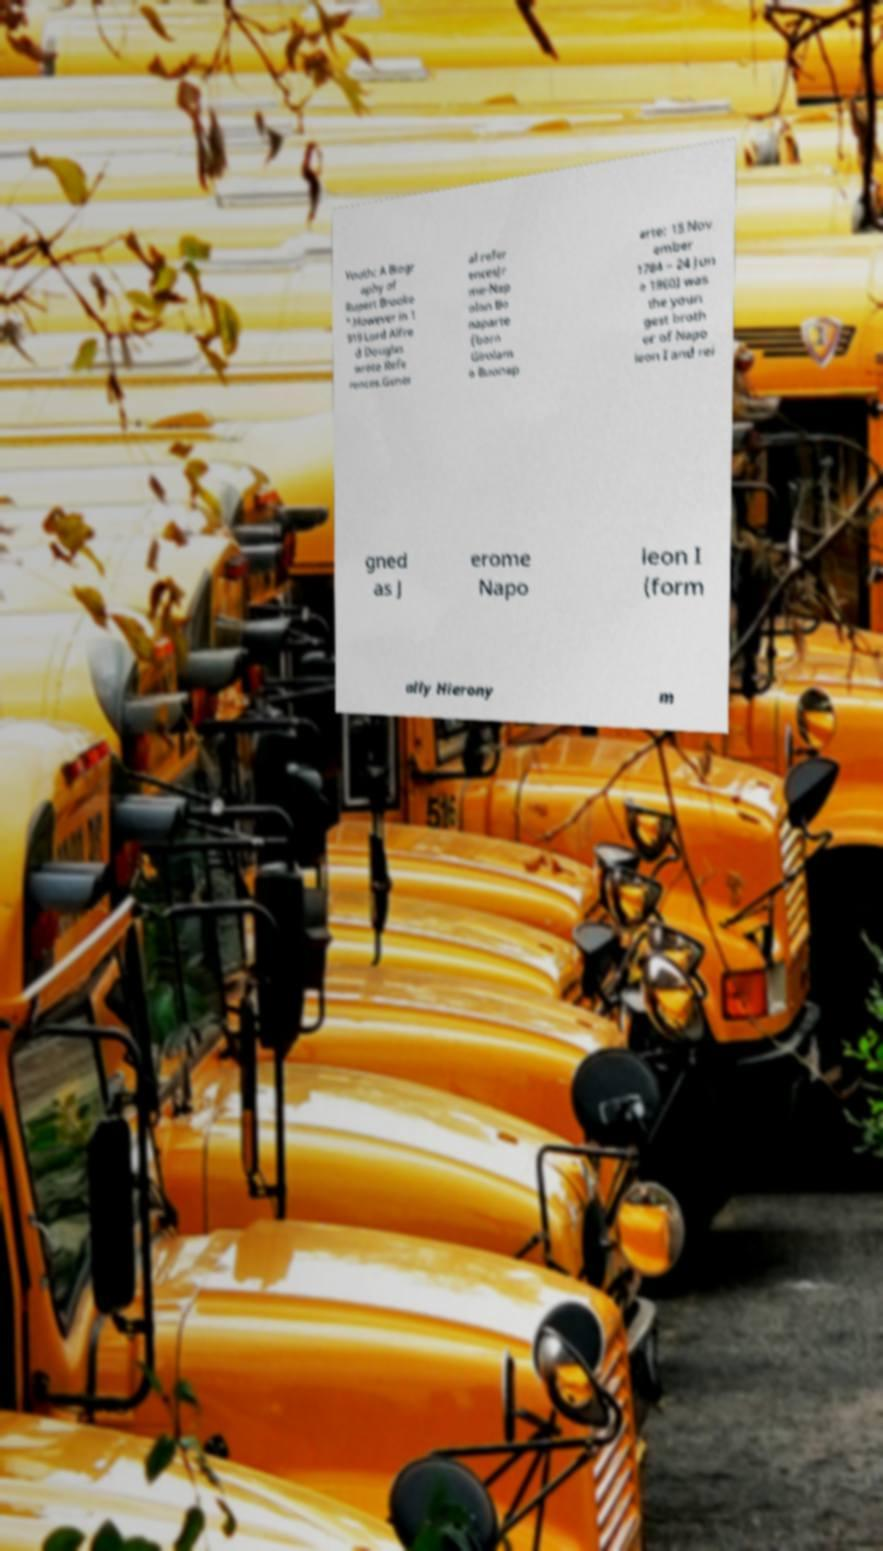What messages or text are displayed in this image? I need them in a readable, typed format. Youth: A Biogr aphy of Rupert Brooke ".However in 1 919 Lord Alfre d Douglas wrote Refe rences.Gener al refer encesJr me-Nap olon Bo naparte (born Girolam o Buonap arte; 15 Nov ember 1784 – 24 Jun e 1860) was the youn gest broth er of Napo leon I and rei gned as J erome Napo leon I (form ally Hierony m 